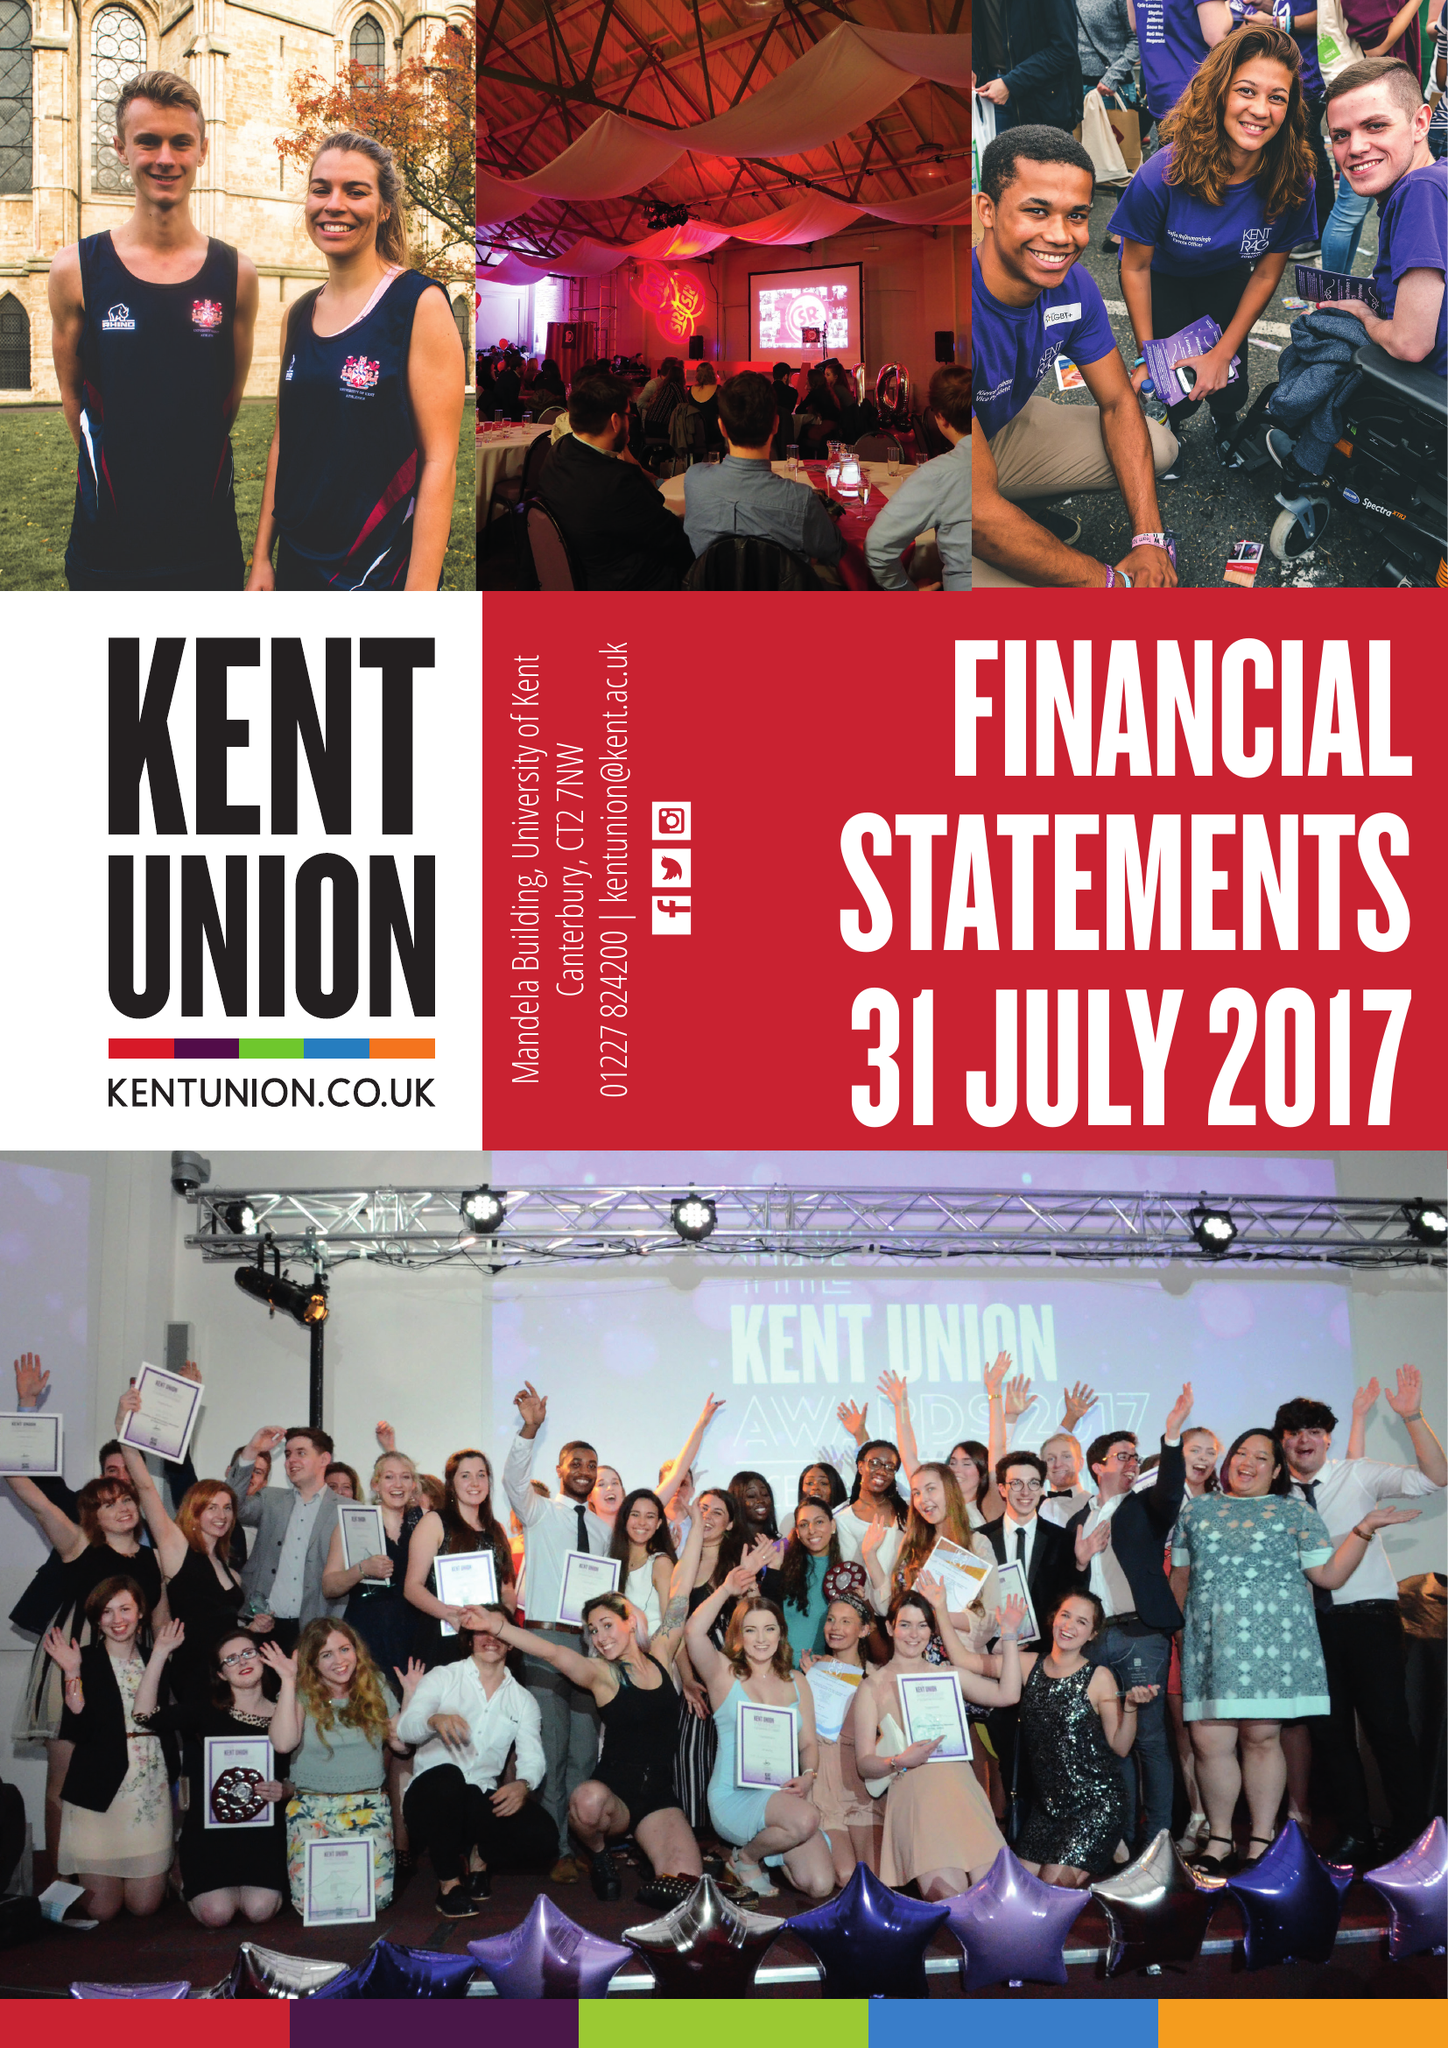What is the value for the report_date?
Answer the question using a single word or phrase. 2017-07-31 